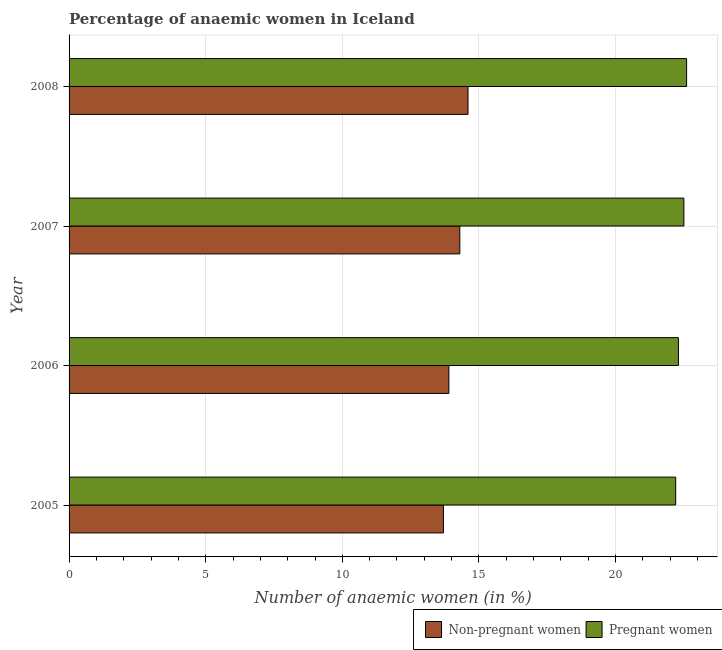How many different coloured bars are there?
Your answer should be compact. 2. How many groups of bars are there?
Provide a succinct answer. 4. Are the number of bars per tick equal to the number of legend labels?
Your answer should be compact. Yes. How many bars are there on the 1st tick from the top?
Make the answer very short. 2. In how many cases, is the number of bars for a given year not equal to the number of legend labels?
Offer a terse response. 0. What is the percentage of pregnant anaemic women in 2007?
Provide a succinct answer. 22.5. Across all years, what is the maximum percentage of non-pregnant anaemic women?
Give a very brief answer. 14.6. Across all years, what is the minimum percentage of pregnant anaemic women?
Your answer should be very brief. 22.2. In which year was the percentage of non-pregnant anaemic women maximum?
Keep it short and to the point. 2008. What is the total percentage of pregnant anaemic women in the graph?
Offer a terse response. 89.6. What is the difference between the percentage of non-pregnant anaemic women in 2005 and the percentage of pregnant anaemic women in 2007?
Offer a very short reply. -8.8. What is the average percentage of pregnant anaemic women per year?
Keep it short and to the point. 22.4. What is the ratio of the percentage of pregnant anaemic women in 2005 to that in 2006?
Your response must be concise. 1. Is the difference between the percentage of pregnant anaemic women in 2005 and 2006 greater than the difference between the percentage of non-pregnant anaemic women in 2005 and 2006?
Keep it short and to the point. Yes. What is the difference between the highest and the second highest percentage of pregnant anaemic women?
Make the answer very short. 0.1. What does the 1st bar from the top in 2007 represents?
Keep it short and to the point. Pregnant women. What does the 2nd bar from the bottom in 2005 represents?
Make the answer very short. Pregnant women. How many bars are there?
Provide a succinct answer. 8. Where does the legend appear in the graph?
Your response must be concise. Bottom right. How many legend labels are there?
Offer a terse response. 2. What is the title of the graph?
Keep it short and to the point. Percentage of anaemic women in Iceland. Does "Subsidies" appear as one of the legend labels in the graph?
Provide a succinct answer. No. What is the label or title of the X-axis?
Give a very brief answer. Number of anaemic women (in %). What is the label or title of the Y-axis?
Keep it short and to the point. Year. What is the Number of anaemic women (in %) of Non-pregnant women in 2005?
Your answer should be compact. 13.7. What is the Number of anaemic women (in %) in Pregnant women in 2005?
Offer a very short reply. 22.2. What is the Number of anaemic women (in %) in Pregnant women in 2006?
Your response must be concise. 22.3. What is the Number of anaemic women (in %) of Pregnant women in 2008?
Ensure brevity in your answer.  22.6. Across all years, what is the maximum Number of anaemic women (in %) of Pregnant women?
Offer a terse response. 22.6. Across all years, what is the minimum Number of anaemic women (in %) in Non-pregnant women?
Offer a very short reply. 13.7. What is the total Number of anaemic women (in %) in Non-pregnant women in the graph?
Provide a succinct answer. 56.5. What is the total Number of anaemic women (in %) of Pregnant women in the graph?
Provide a succinct answer. 89.6. What is the difference between the Number of anaemic women (in %) in Pregnant women in 2005 and that in 2006?
Your response must be concise. -0.1. What is the difference between the Number of anaemic women (in %) of Non-pregnant women in 2005 and that in 2007?
Your answer should be very brief. -0.6. What is the difference between the Number of anaemic women (in %) in Pregnant women in 2005 and that in 2008?
Provide a succinct answer. -0.4. What is the difference between the Number of anaemic women (in %) in Pregnant women in 2006 and that in 2008?
Provide a succinct answer. -0.3. What is the difference between the Number of anaemic women (in %) of Non-pregnant women in 2005 and the Number of anaemic women (in %) of Pregnant women in 2007?
Offer a terse response. -8.8. What is the difference between the Number of anaemic women (in %) of Non-pregnant women in 2006 and the Number of anaemic women (in %) of Pregnant women in 2007?
Your answer should be compact. -8.6. What is the average Number of anaemic women (in %) in Non-pregnant women per year?
Provide a succinct answer. 14.12. What is the average Number of anaemic women (in %) of Pregnant women per year?
Offer a terse response. 22.4. In the year 2005, what is the difference between the Number of anaemic women (in %) of Non-pregnant women and Number of anaemic women (in %) of Pregnant women?
Provide a short and direct response. -8.5. In the year 2007, what is the difference between the Number of anaemic women (in %) of Non-pregnant women and Number of anaemic women (in %) of Pregnant women?
Provide a short and direct response. -8.2. In the year 2008, what is the difference between the Number of anaemic women (in %) in Non-pregnant women and Number of anaemic women (in %) in Pregnant women?
Ensure brevity in your answer.  -8. What is the ratio of the Number of anaemic women (in %) of Non-pregnant women in 2005 to that in 2006?
Offer a terse response. 0.99. What is the ratio of the Number of anaemic women (in %) in Non-pregnant women in 2005 to that in 2007?
Your answer should be very brief. 0.96. What is the ratio of the Number of anaemic women (in %) of Pregnant women in 2005 to that in 2007?
Ensure brevity in your answer.  0.99. What is the ratio of the Number of anaemic women (in %) of Non-pregnant women in 2005 to that in 2008?
Ensure brevity in your answer.  0.94. What is the ratio of the Number of anaemic women (in %) of Pregnant women in 2005 to that in 2008?
Ensure brevity in your answer.  0.98. What is the ratio of the Number of anaemic women (in %) in Non-pregnant women in 2006 to that in 2008?
Your response must be concise. 0.95. What is the ratio of the Number of anaemic women (in %) in Pregnant women in 2006 to that in 2008?
Your response must be concise. 0.99. What is the ratio of the Number of anaemic women (in %) of Non-pregnant women in 2007 to that in 2008?
Offer a very short reply. 0.98. What is the difference between the highest and the second highest Number of anaemic women (in %) in Pregnant women?
Keep it short and to the point. 0.1. What is the difference between the highest and the lowest Number of anaemic women (in %) of Pregnant women?
Your response must be concise. 0.4. 